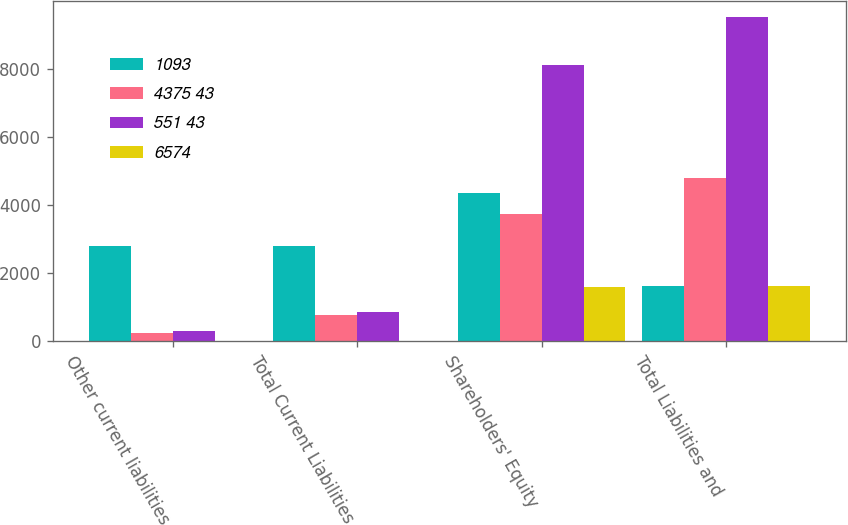<chart> <loc_0><loc_0><loc_500><loc_500><stacked_bar_chart><ecel><fcel>Other current liabilities<fcel>Total Current Liabilities<fcel>Shareholders' Equity<fcel>Total Liabilities and<nl><fcel>1093<fcel>2790<fcel>2808<fcel>4352<fcel>1621<nl><fcel>4375 43<fcel>251<fcel>766<fcel>3732<fcel>4782<nl><fcel>551 43<fcel>296<fcel>846<fcel>8098<fcel>9508<nl><fcel>6574<fcel>24<fcel>24<fcel>1597<fcel>1621<nl></chart> 